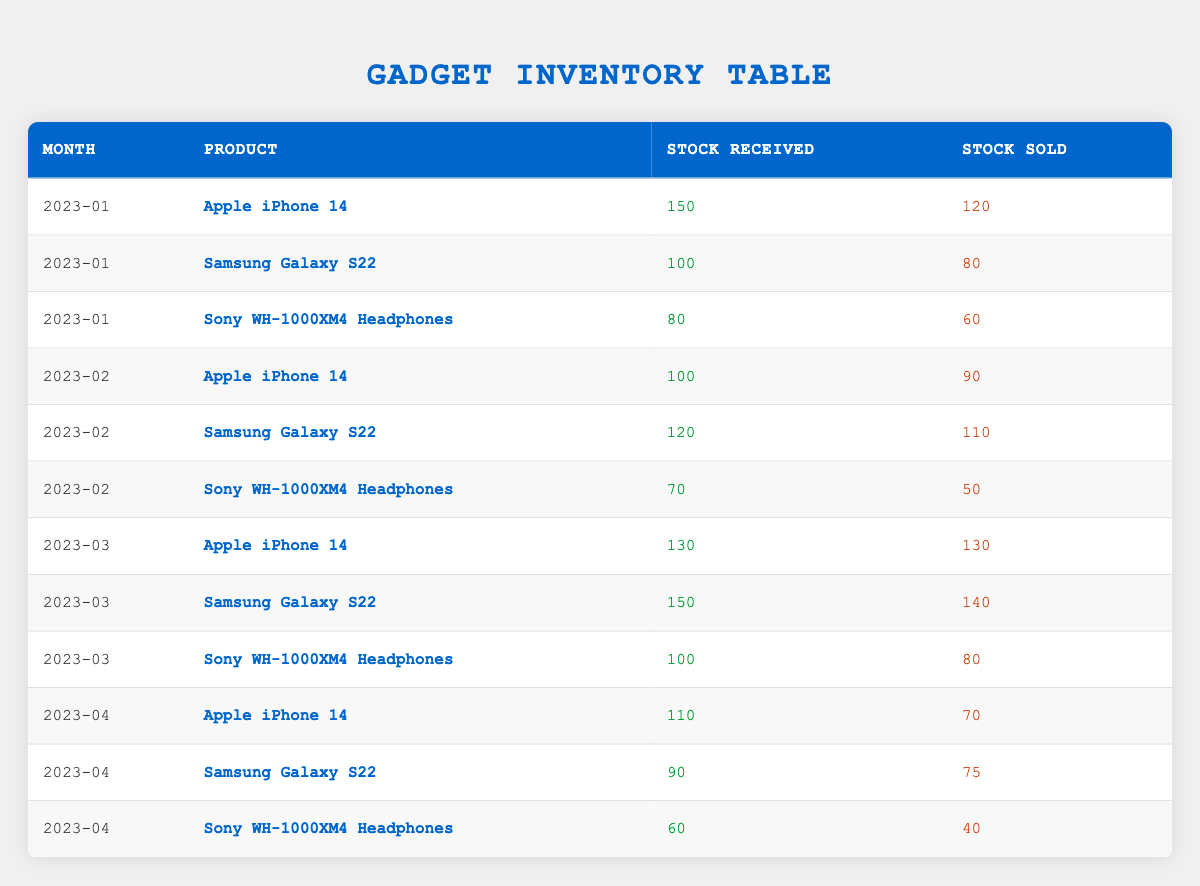What's the total stock received for the Apple iPhone 14 from January to April 2023? The stock received for Apple iPhone 14 in January is 150, in February is 100, in March is 130, and in April is 110. Adding these values together gives 150 + 100 + 130 + 110 = 490.
Answer: 490 How many Sony WH-1000XM4 Headphones were sold in February 2023? From the table, the stock sold for Sony WH-1000XM4 Headphones in February 2023 is directly listed as 50.
Answer: 50 Which product had the highest stock sold in March 2023? In March 2023, the stock sold values are: Apple iPhone 14 (130), Samsung Galaxy S22 (140), and Sony WH-1000XM4 Headphones (80). The highest value among these is 140 for Samsung Galaxy S22.
Answer: Samsung Galaxy S22 Was there a month in which the Apple iPhone 14 sold more than it was received? Looking at the table, in March, 130 units were received and 130 sold, which is equal. No month shows more sells than receives; therefore, the answer is no.
Answer: No What is the average stock sold for the Samsung Galaxy S22 over the four months? The stock sold for Samsung Galaxy S22 across four months is: 80 (January) + 110 (February) + 140 (March) + 75 (April) = 405. The average is calculated by dividing the total by the number of months (4), which gives 405 / 4 = 101.25.
Answer: 101.25 How much more stock was received for the Apple iPhone 14 in January than in April 2023? The stock received in January for Apple iPhone 14 is 150, and in April, it is 110. The difference is 150 - 110 = 40.
Answer: 40 Did the stock received for Sony WH-1000XM4 Headphones increase every month from January to April 2023? The stock received for Sony WH-1000XM4 Headphones is as follows: 80 (January), 70 (February), 100 (March), and 60 (April). The values do not consistently increase, as it decreased from January to February.
Answer: No What is the total stock received for all products in March 2023? In March 2023, the stocks received for all products are: Apple iPhone 14 (130), Samsung Galaxy S22 (150), and Sony WH-1000XM4 Headphones (100). The total is 130 + 150 + 100 = 380.
Answer: 380 